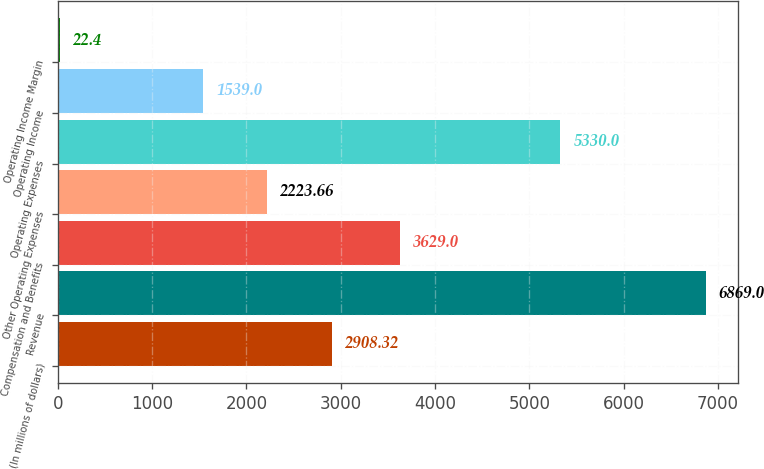<chart> <loc_0><loc_0><loc_500><loc_500><bar_chart><fcel>(In millions of dollars)<fcel>Revenue<fcel>Compensation and Benefits<fcel>Other Operating Expenses<fcel>Operating Expenses<fcel>Operating Income<fcel>Operating Income Margin<nl><fcel>2908.32<fcel>6869<fcel>3629<fcel>2223.66<fcel>5330<fcel>1539<fcel>22.4<nl></chart> 